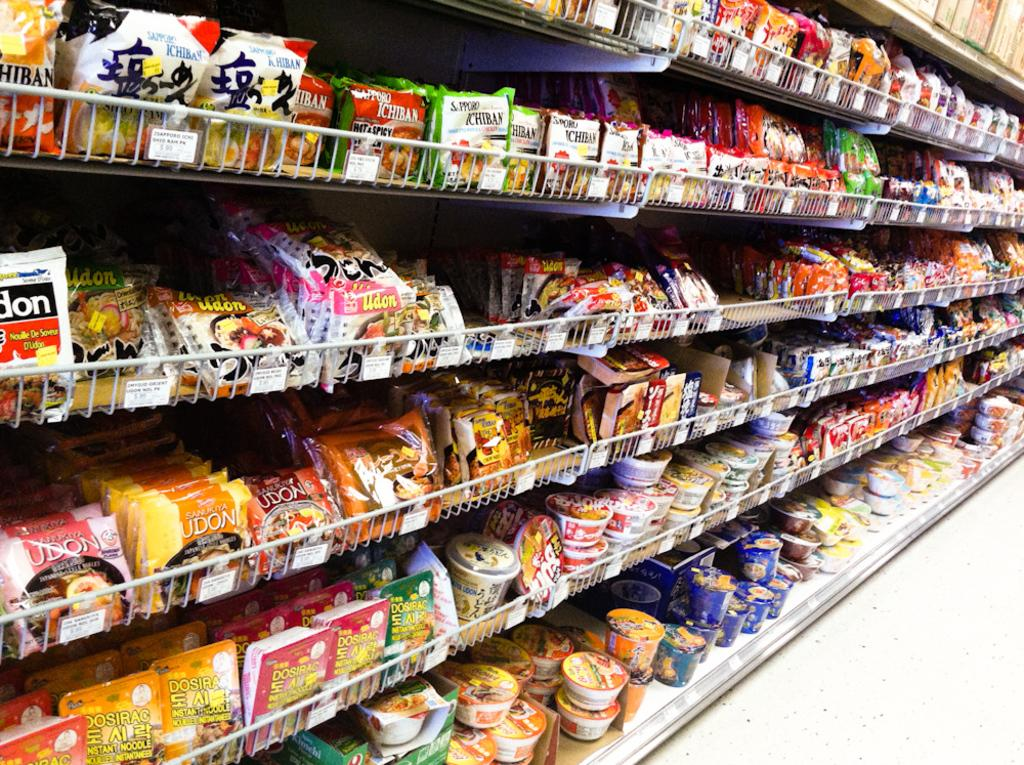Provide a one-sentence caption for the provided image. A row of ramen noodles showing brands such as Hiban. 